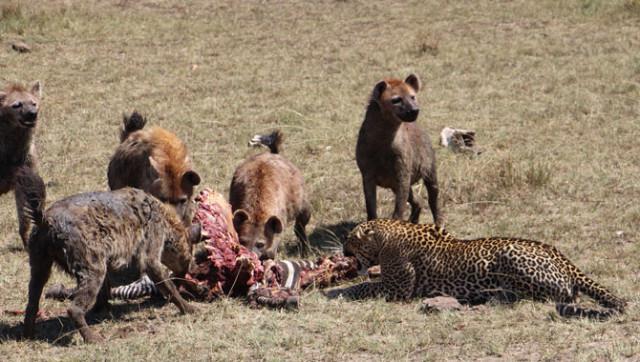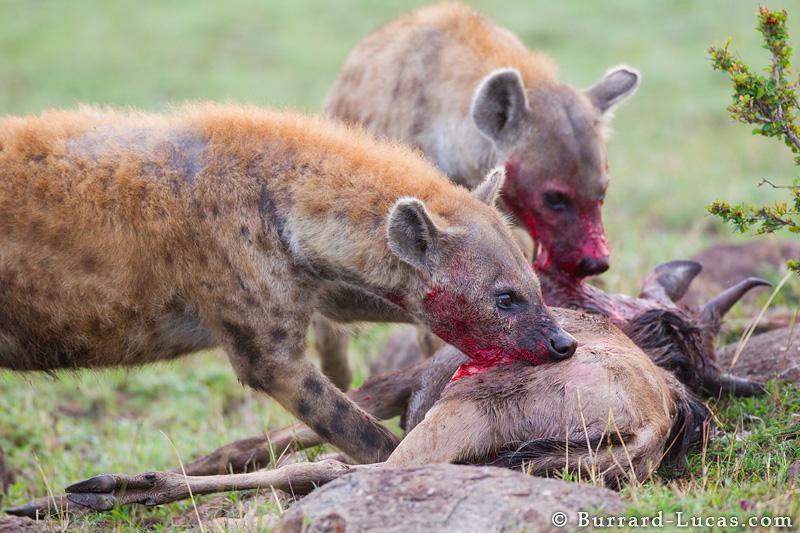The first image is the image on the left, the second image is the image on the right. Considering the images on both sides, is "Both images in the pair show two or more hyenas feasting a recent kill." valid? Answer yes or no. Yes. 